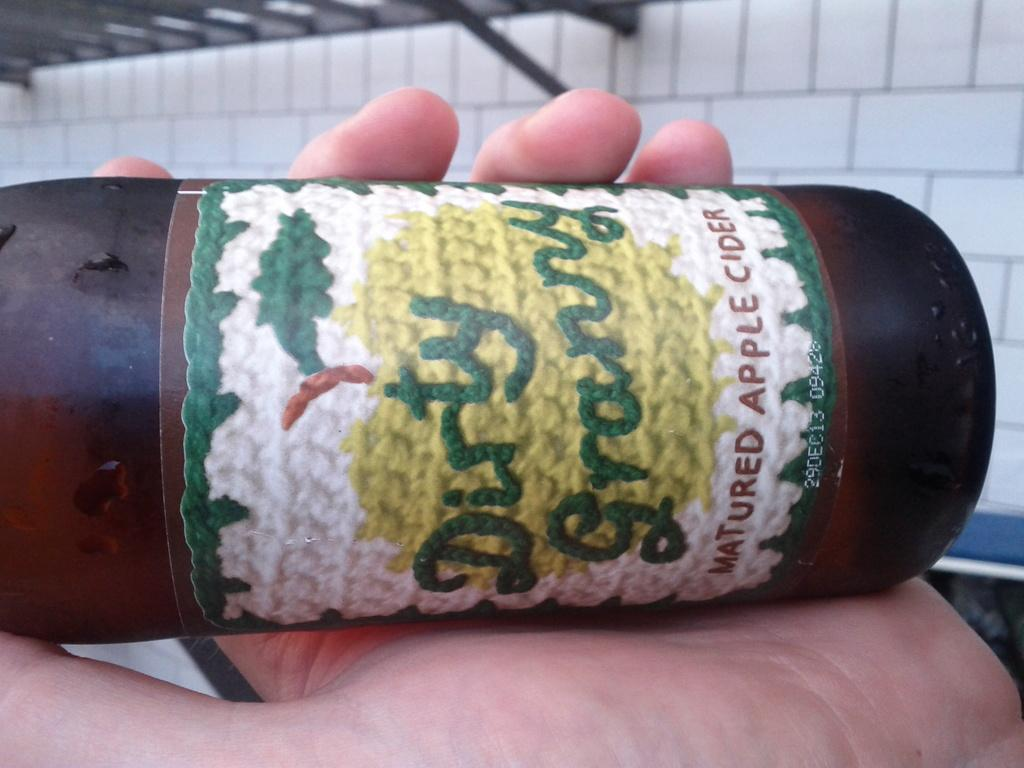What is the human hand holding in the image? The human hand is holding a bottle in the image. What can be seen on the bottle? The bottle has a label on it. What is visible at the top of the image? There is a wall visible at the top of the image. How many cables can be seen hanging from the wall in the image? There are no cables visible in the image; only a wall is present at the top. 